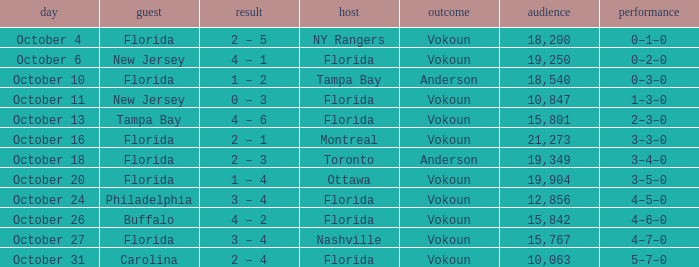Which team was home on October 13? Florida. 